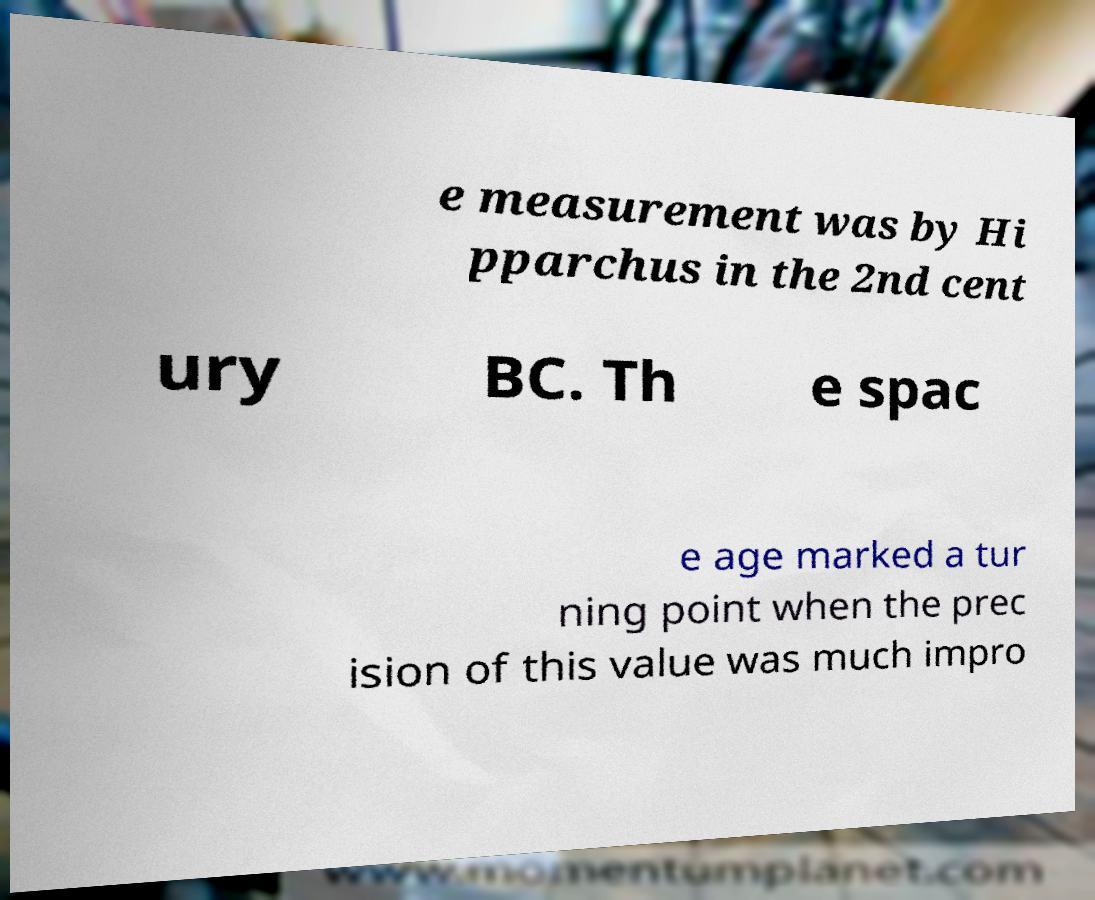Please identify and transcribe the text found in this image. e measurement was by Hi pparchus in the 2nd cent ury BC. Th e spac e age marked a tur ning point when the prec ision of this value was much impro 